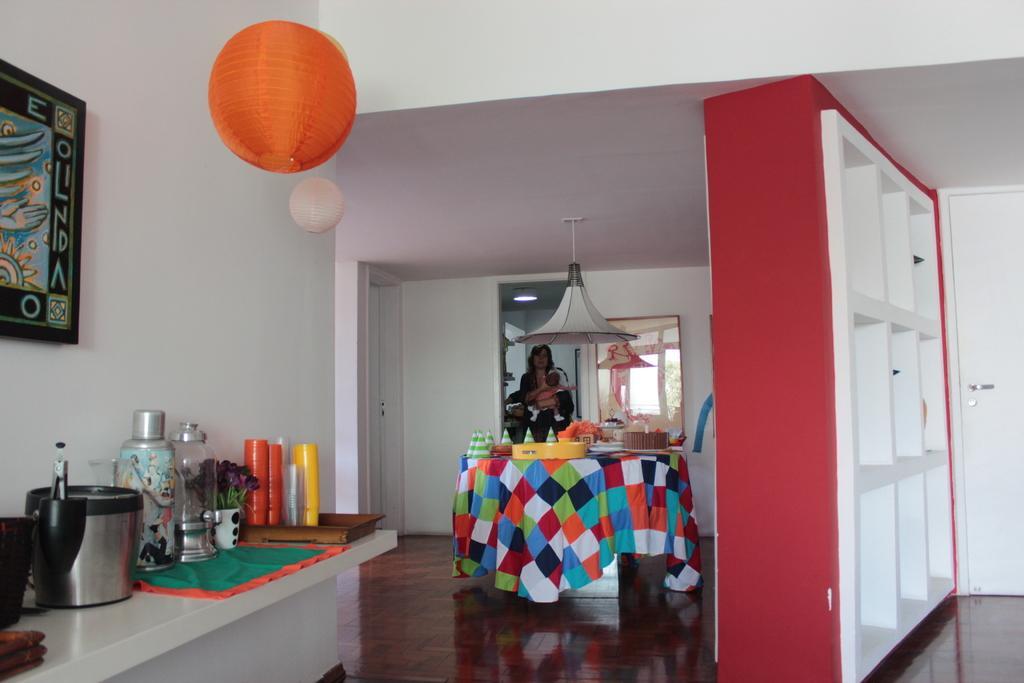In one or two sentences, can you explain what this image depicts? On the left side of the image there is a table with bottle, cup with flowers and many other items on it. Behind the table there is a wall with frame. At the top there are orange and white color balls hanging. In the background there is a table with cloth and many items on it. Above the table there is a lamp. Behind the table there is a lady standing and holding the baby in the hand. Behind the lady there is a wall with frame and a door. On the right side of the image there is a door and also there is a cupboard. 